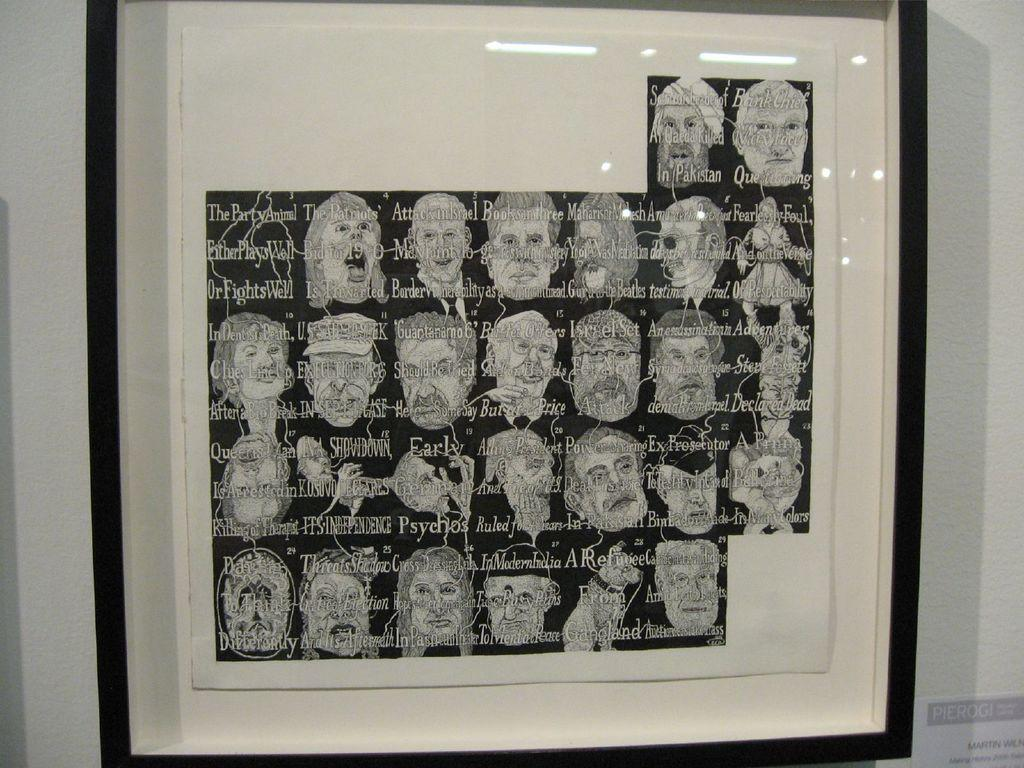What is on the wall in the image? There is a frame with pictures and text, as well as a paper with text at the bottom right. Can you describe the content of the frame? The frame contains pictures and text, but the specific content cannot be determined from the image. What is the location of the paper with text on the wall? The paper with text is at the bottom right of the wall. How many plastic chairs are visible in the image? There are no plastic chairs present in the image. What type of boot is hanging on the wall in the image? There is no boot present in the image. 